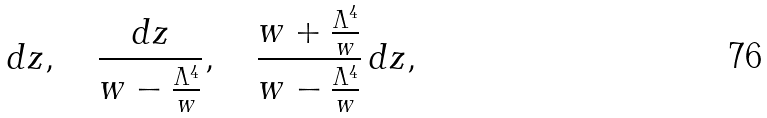Convert formula to latex. <formula><loc_0><loc_0><loc_500><loc_500>d z , \quad \frac { d z } { w - \frac { \Lambda ^ { 4 } } { w } } , \quad \frac { w + \frac { \Lambda ^ { 4 } } { w } } { w - \frac { \Lambda ^ { 4 } } { w } } \, d z ,</formula> 